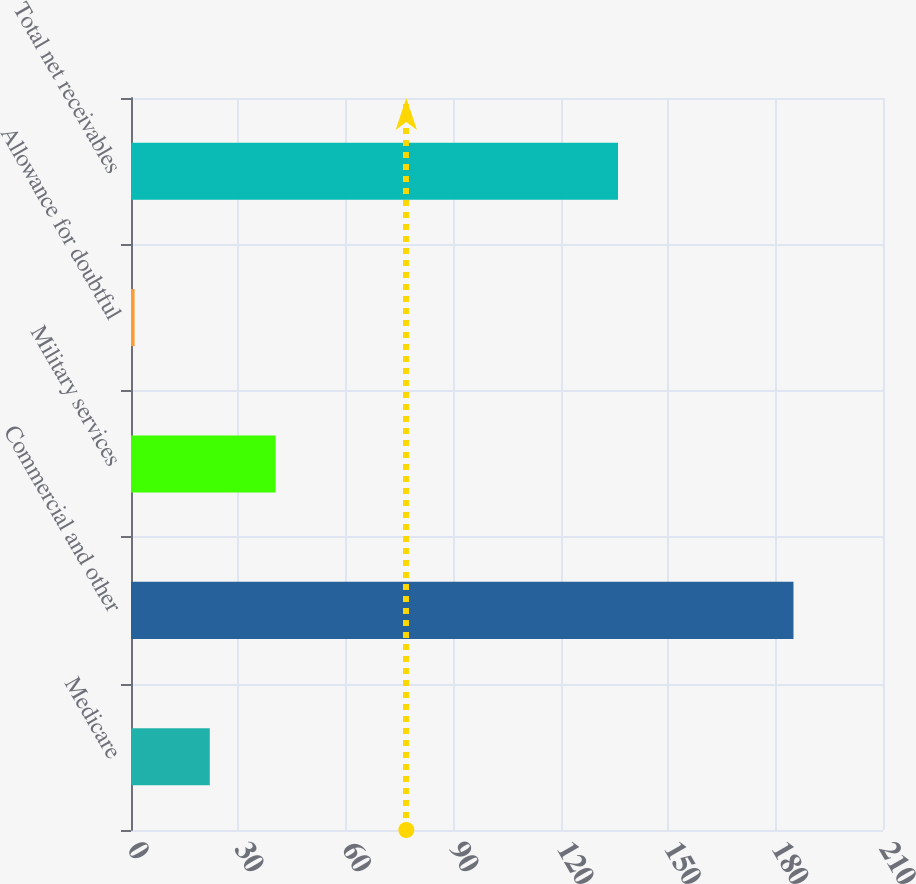Convert chart to OTSL. <chart><loc_0><loc_0><loc_500><loc_500><bar_chart><fcel>Medicare<fcel>Commercial and other<fcel>Military services<fcel>Allowance for doubtful<fcel>Total net receivables<nl><fcel>22<fcel>185<fcel>40.4<fcel>1<fcel>136<nl></chart> 